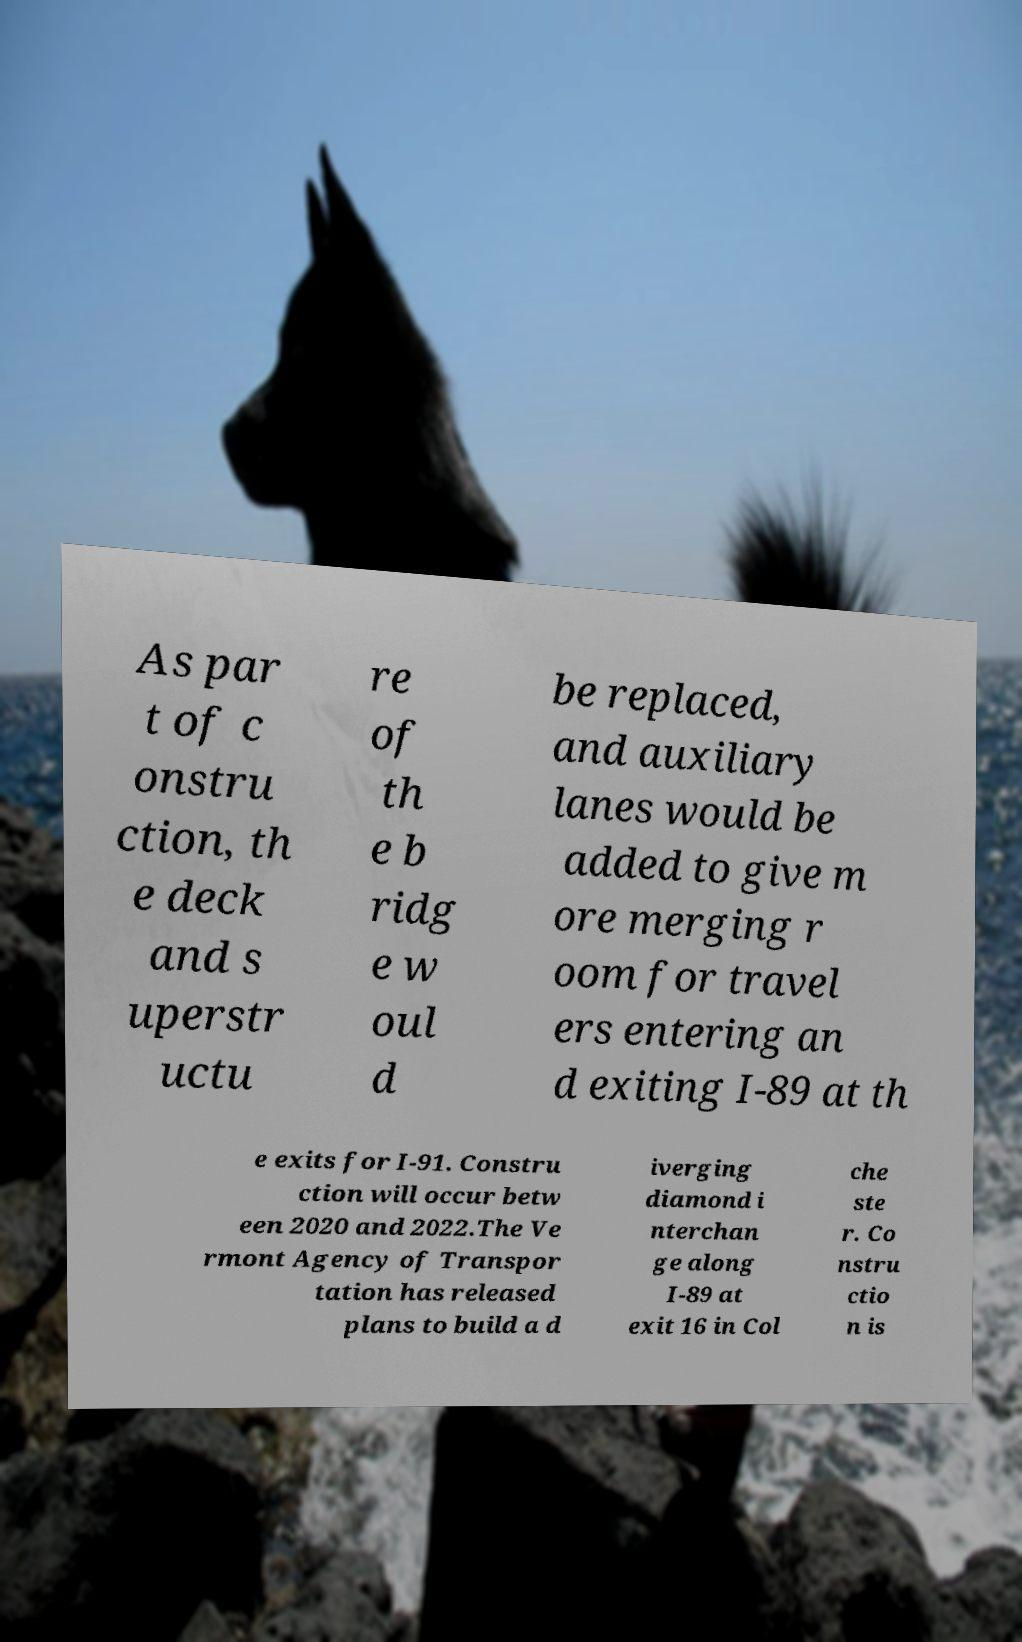What messages or text are displayed in this image? I need them in a readable, typed format. As par t of c onstru ction, th e deck and s uperstr uctu re of th e b ridg e w oul d be replaced, and auxiliary lanes would be added to give m ore merging r oom for travel ers entering an d exiting I-89 at th e exits for I-91. Constru ction will occur betw een 2020 and 2022.The Ve rmont Agency of Transpor tation has released plans to build a d iverging diamond i nterchan ge along I-89 at exit 16 in Col che ste r. Co nstru ctio n is 